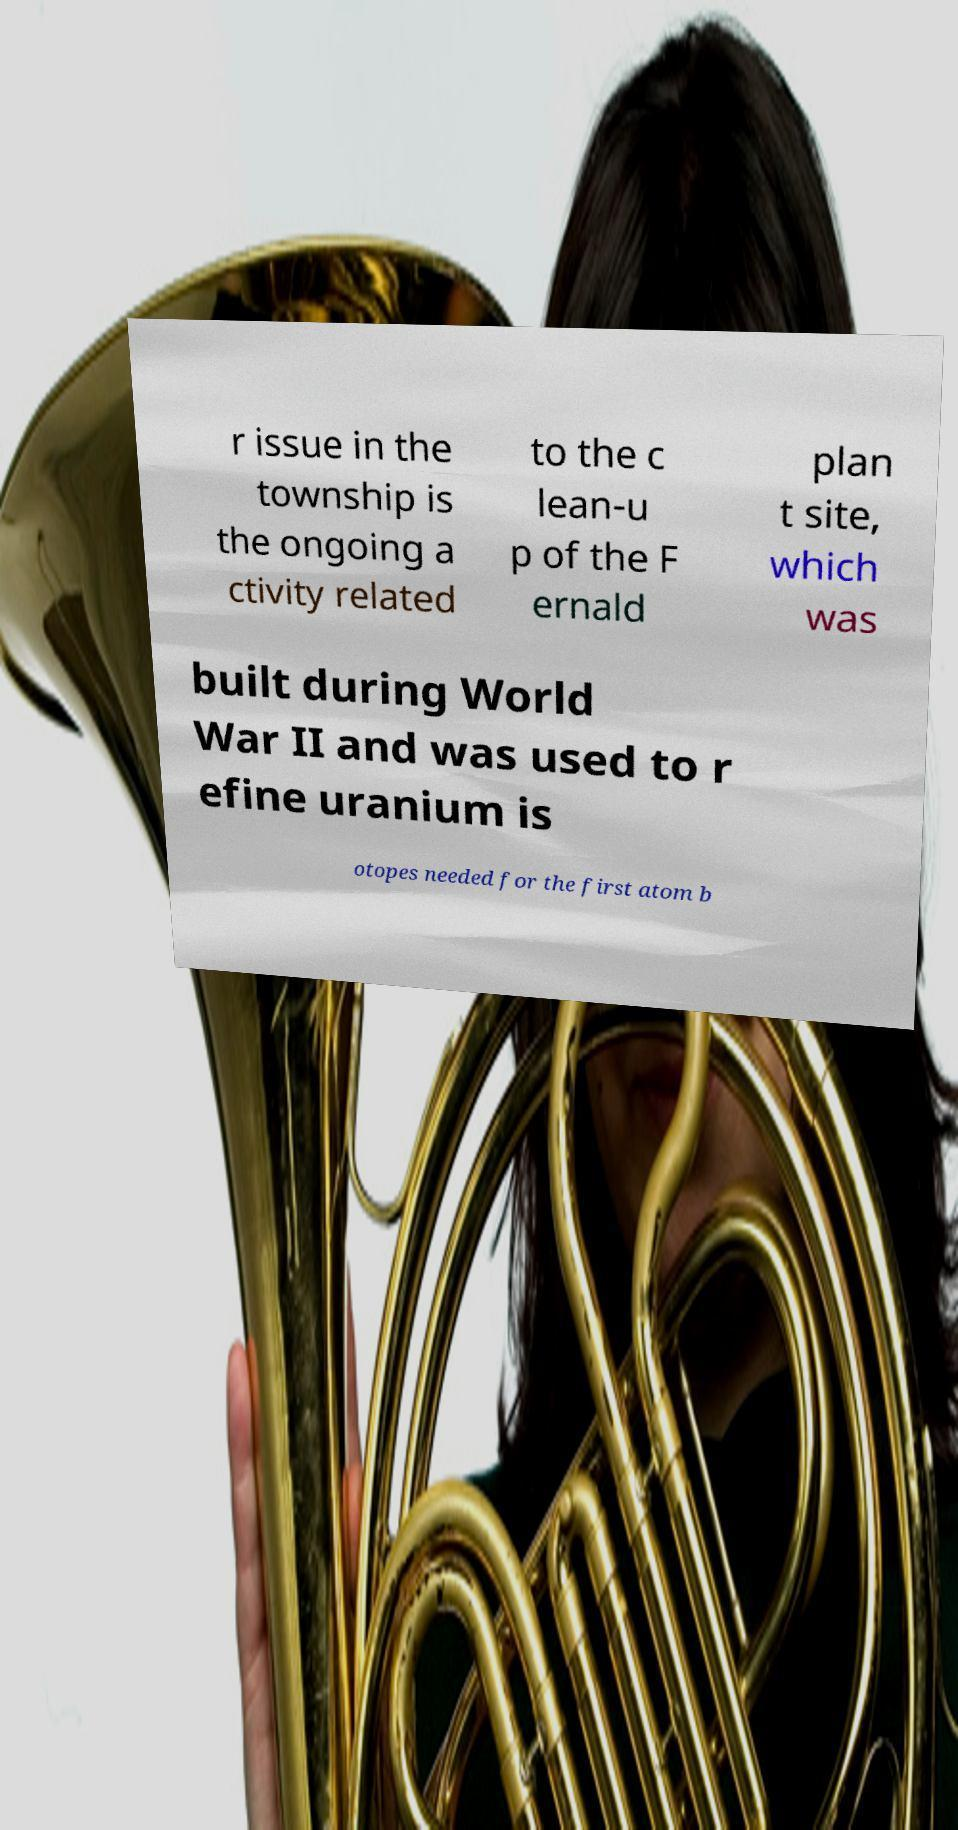What messages or text are displayed in this image? I need them in a readable, typed format. r issue in the township is the ongoing a ctivity related to the c lean-u p of the F ernald plan t site, which was built during World War II and was used to r efine uranium is otopes needed for the first atom b 